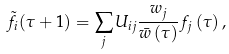Convert formula to latex. <formula><loc_0><loc_0><loc_500><loc_500>\tilde { f } _ { i } ( \tau + 1 ) = \sum _ { j } U _ { i j } \frac { w _ { j } } { \bar { w } \left ( \tau \right ) } f _ { j } \left ( \tau \right ) ,</formula> 